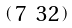Convert formula to latex. <formula><loc_0><loc_0><loc_500><loc_500>\begin{psmallmatrix} 7 & 3 2 \end{psmallmatrix}</formula> 